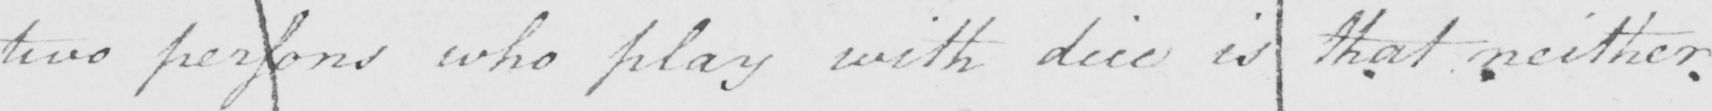Please provide the text content of this handwritten line. two persons who play with dice is that neither 